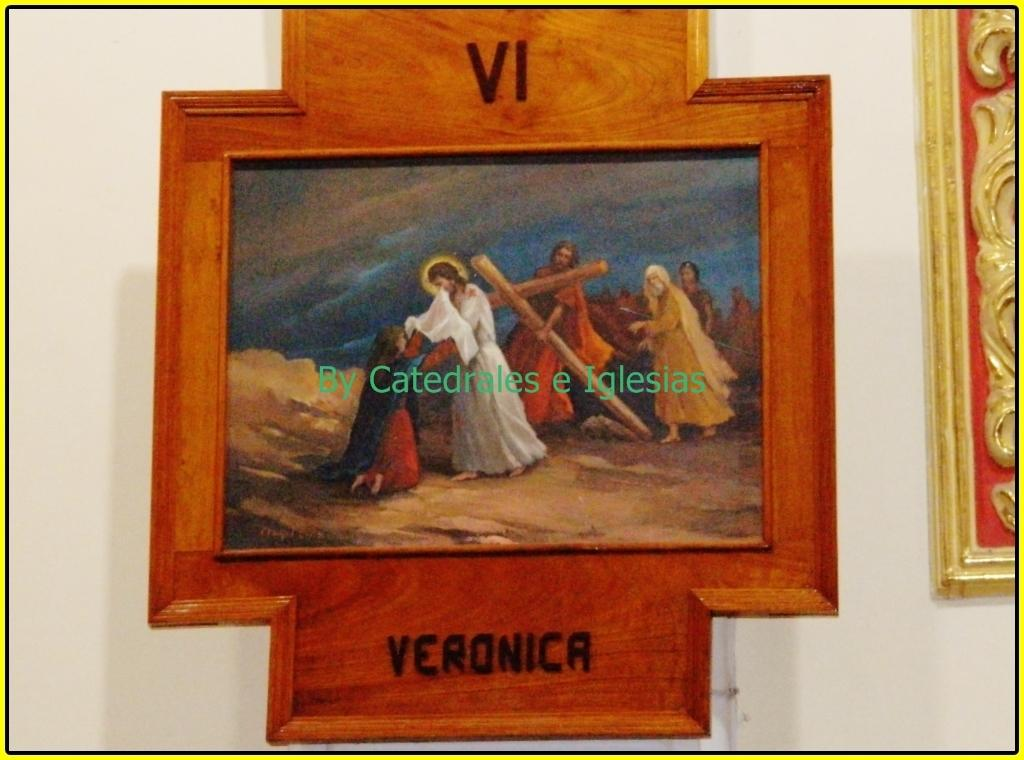<image>
Create a compact narrative representing the image presented. Picture of Jesus holding a cross and the name Veronica under it. 